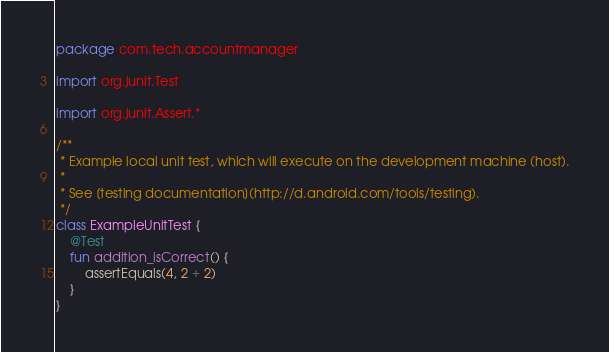<code> <loc_0><loc_0><loc_500><loc_500><_Kotlin_>package com.tech.accountmanager

import org.junit.Test

import org.junit.Assert.*

/**
 * Example local unit test, which will execute on the development machine (host).
 *
 * See [testing documentation](http://d.android.com/tools/testing).
 */
class ExampleUnitTest {
    @Test
    fun addition_isCorrect() {
        assertEquals(4, 2 + 2)
    }
}
</code> 